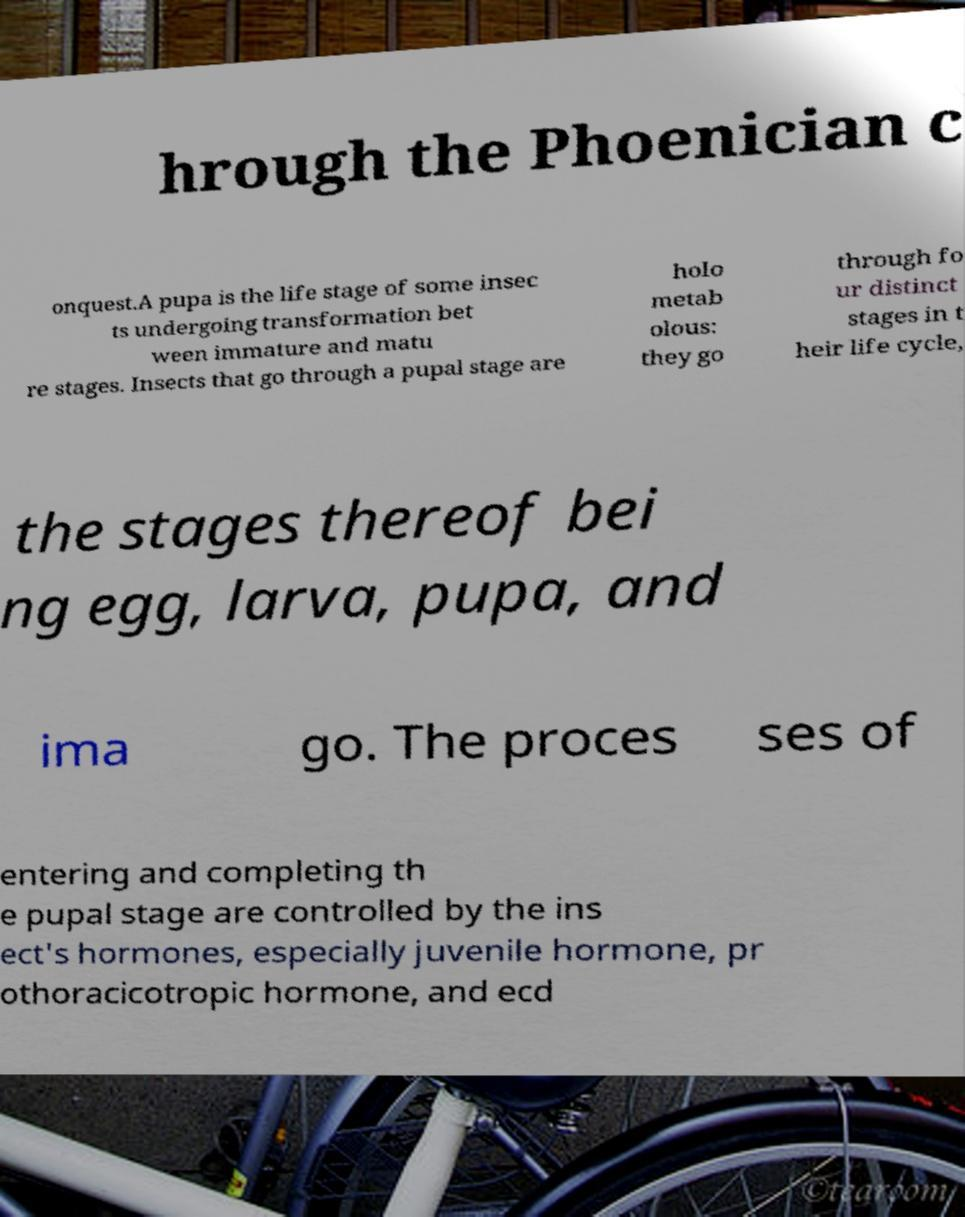What messages or text are displayed in this image? I need them in a readable, typed format. hrough the Phoenician c onquest.A pupa is the life stage of some insec ts undergoing transformation bet ween immature and matu re stages. Insects that go through a pupal stage are holo metab olous: they go through fo ur distinct stages in t heir life cycle, the stages thereof bei ng egg, larva, pupa, and ima go. The proces ses of entering and completing th e pupal stage are controlled by the ins ect's hormones, especially juvenile hormone, pr othoracicotropic hormone, and ecd 